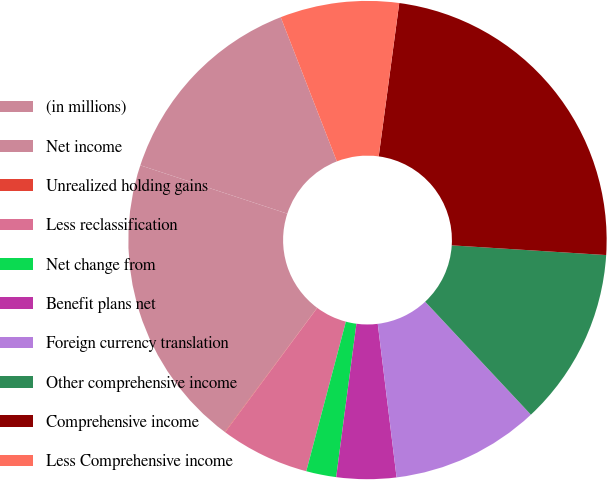Convert chart to OTSL. <chart><loc_0><loc_0><loc_500><loc_500><pie_chart><fcel>(in millions)<fcel>Net income<fcel>Unrealized holding gains<fcel>Less reclassification<fcel>Net change from<fcel>Benefit plans net<fcel>Foreign currency translation<fcel>Other comprehensive income<fcel>Comprehensive income<fcel>Less Comprehensive income<nl><fcel>14.03%<fcel>19.88%<fcel>0.03%<fcel>6.03%<fcel>2.03%<fcel>4.03%<fcel>10.03%<fcel>12.03%<fcel>23.88%<fcel>8.03%<nl></chart> 